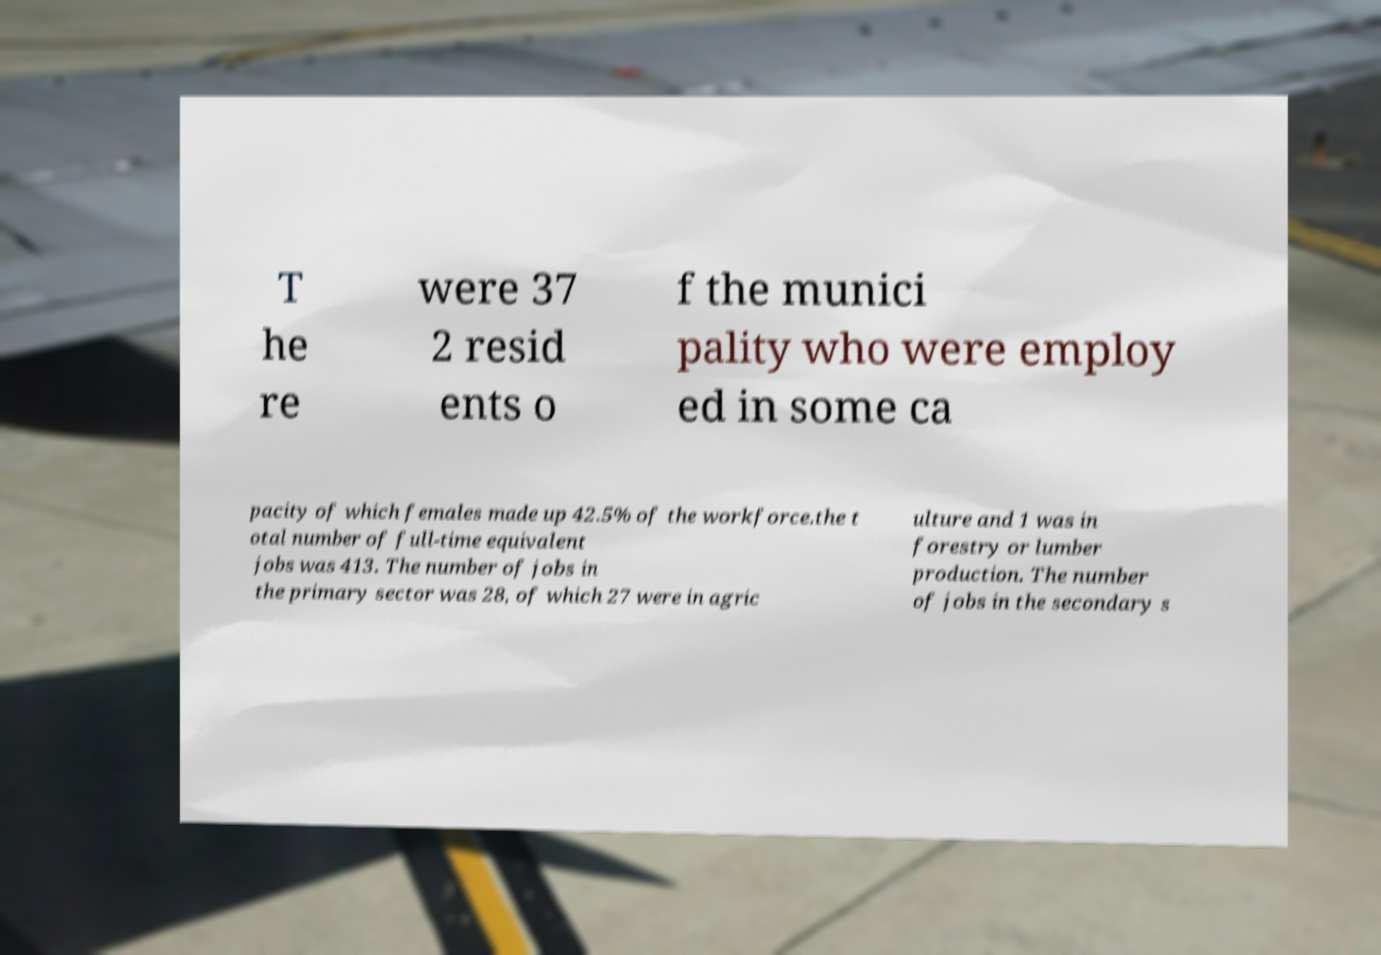Can you read and provide the text displayed in the image?This photo seems to have some interesting text. Can you extract and type it out for me? T he re were 37 2 resid ents o f the munici pality who were employ ed in some ca pacity of which females made up 42.5% of the workforce.the t otal number of full-time equivalent jobs was 413. The number of jobs in the primary sector was 28, of which 27 were in agric ulture and 1 was in forestry or lumber production. The number of jobs in the secondary s 